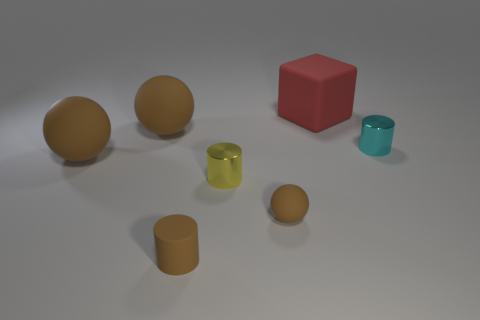Add 1 cyan metallic objects. How many objects exist? 8 Subtract all blocks. How many objects are left? 6 Subtract all red cubes. Subtract all tiny yellow things. How many objects are left? 5 Add 2 yellow shiny cylinders. How many yellow shiny cylinders are left? 3 Add 7 tiny purple cylinders. How many tiny purple cylinders exist? 7 Subtract 0 green spheres. How many objects are left? 7 